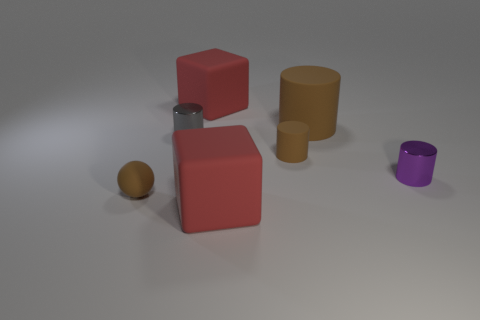Subtract all gray cylinders. How many cylinders are left? 3 Add 1 matte blocks. How many objects exist? 8 Subtract all green cylinders. Subtract all brown cubes. How many cylinders are left? 4 Subtract all spheres. How many objects are left? 6 Subtract 0 yellow spheres. How many objects are left? 7 Subtract all cubes. Subtract all tiny gray objects. How many objects are left? 4 Add 5 big brown matte objects. How many big brown matte objects are left? 6 Add 6 big blue metal cubes. How many big blue metal cubes exist? 6 